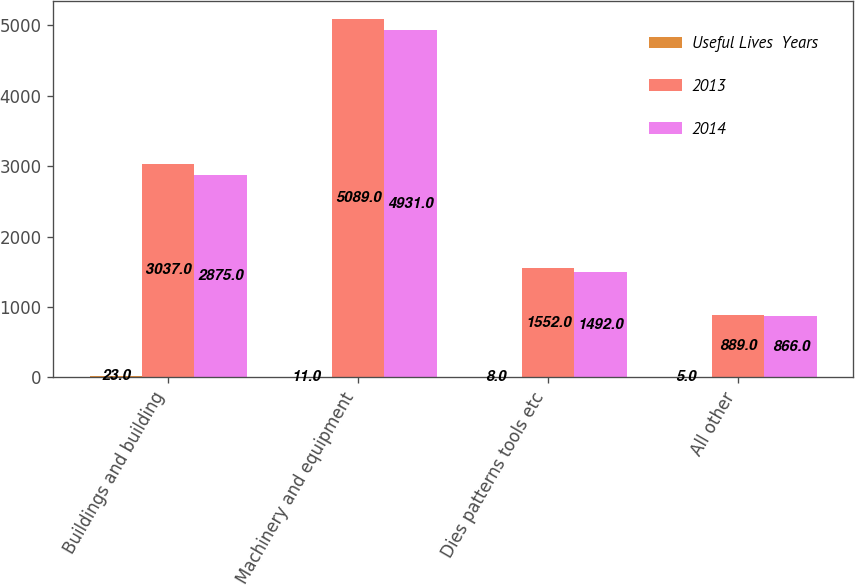Convert chart to OTSL. <chart><loc_0><loc_0><loc_500><loc_500><stacked_bar_chart><ecel><fcel>Buildings and building<fcel>Machinery and equipment<fcel>Dies patterns tools etc<fcel>All other<nl><fcel>Useful Lives  Years<fcel>23<fcel>11<fcel>8<fcel>5<nl><fcel>2013<fcel>3037<fcel>5089<fcel>1552<fcel>889<nl><fcel>2014<fcel>2875<fcel>4931<fcel>1492<fcel>866<nl></chart> 